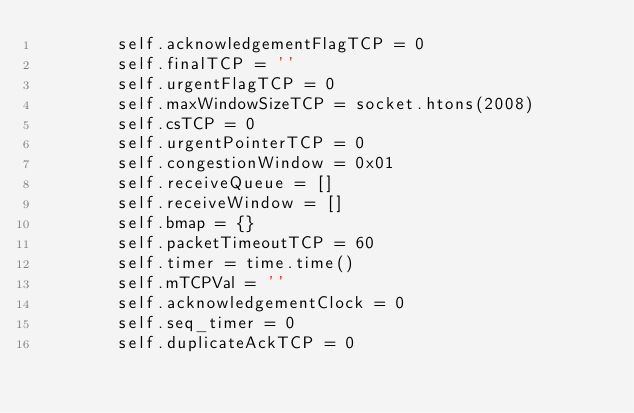Convert code to text. <code><loc_0><loc_0><loc_500><loc_500><_Python_>        self.acknowledgementFlagTCP = 0
        self.finalTCP = ''
        self.urgentFlagTCP = 0
        self.maxWindowSizeTCP = socket.htons(2008)
        self.csTCP = 0
        self.urgentPointerTCP = 0
        self.congestionWindow = 0x01
        self.receiveQueue = []
        self.receiveWindow = []
        self.bmap = {}
        self.packetTimeoutTCP = 60
        self.timer = time.time()
        self.mTCPVal = ''
        self.acknowledgementClock = 0
        self.seq_timer = 0
        self.duplicateAckTCP = 0</code> 